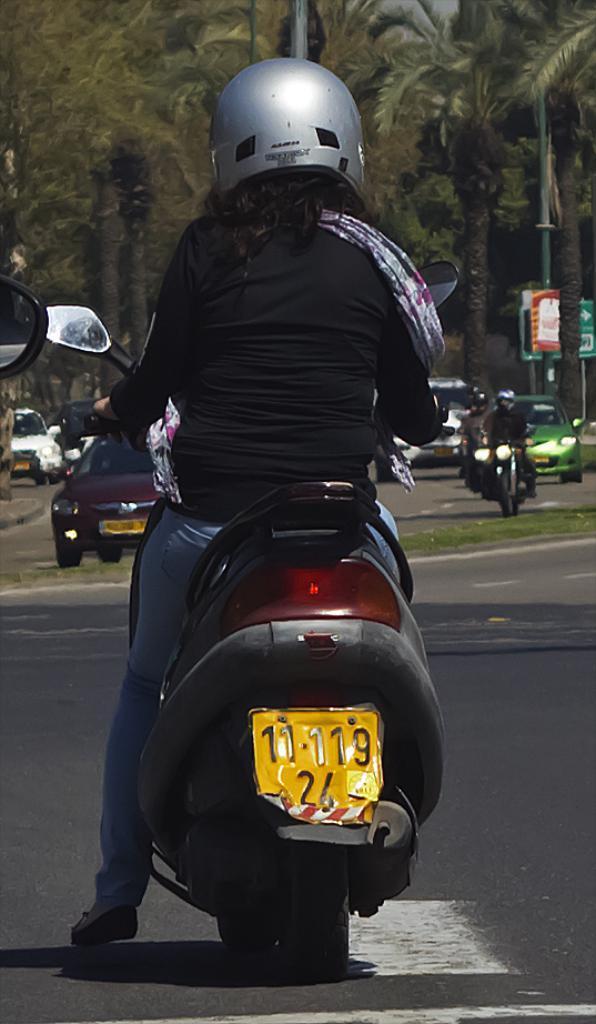In one or two sentences, can you explain what this image depicts? In this image, in the foreground I can see a person sitting on the vehicle and at the back I can see some vehicles on the road and in the background there are some trees. 